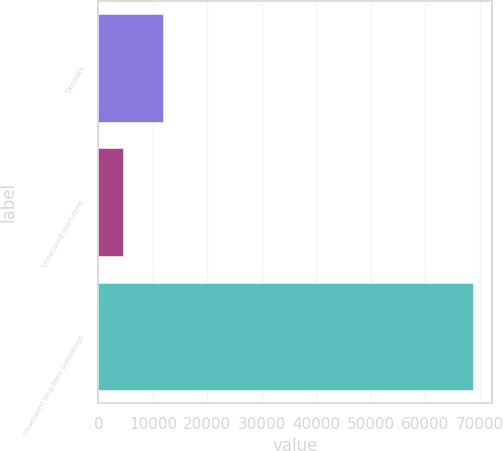<chart> <loc_0><loc_0><loc_500><loc_500><bar_chart><fcel>Deposits<fcel>Unsecured short-term<fcel>Unsecured long-term borrowings<nl><fcel>11924<fcel>4450<fcel>68839<nl></chart> 